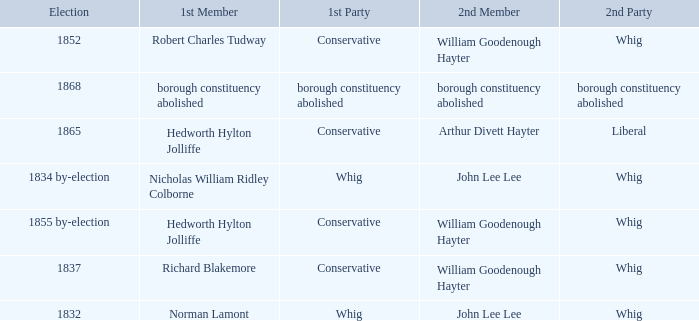What's the 2nd party of 2nd member william goodenough hayter when the 1st member is hedworth hylton jolliffe? Whig. 